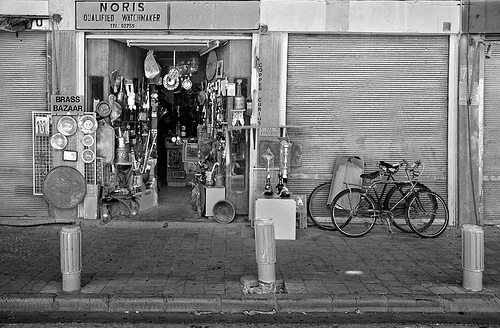Identify the text contained in this image. NORIS OLIALIFIED WATCHMAKER BRASS BAZAAR COPPER 